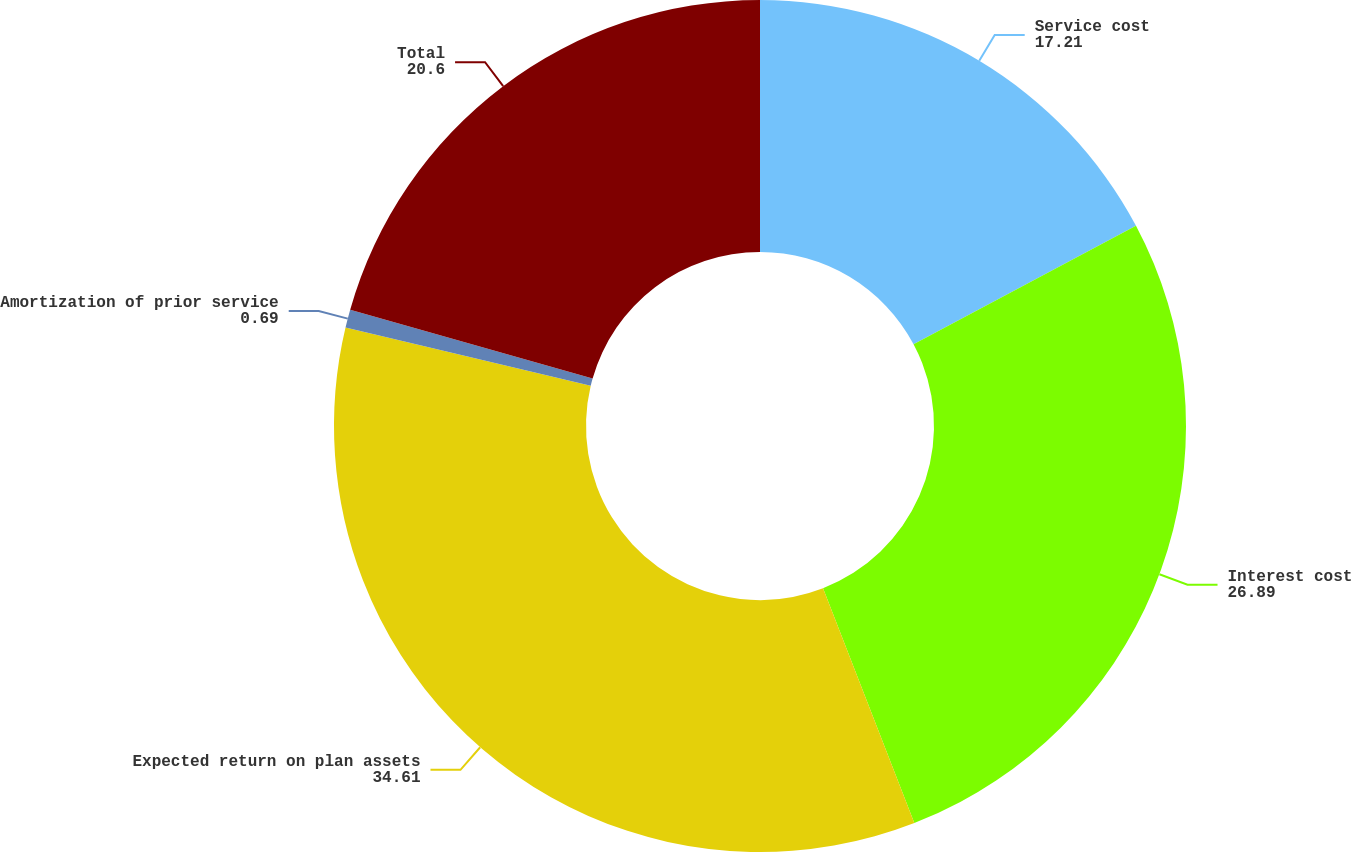Convert chart. <chart><loc_0><loc_0><loc_500><loc_500><pie_chart><fcel>Service cost<fcel>Interest cost<fcel>Expected return on plan assets<fcel>Amortization of prior service<fcel>Total<nl><fcel>17.21%<fcel>26.89%<fcel>34.61%<fcel>0.69%<fcel>20.6%<nl></chart> 